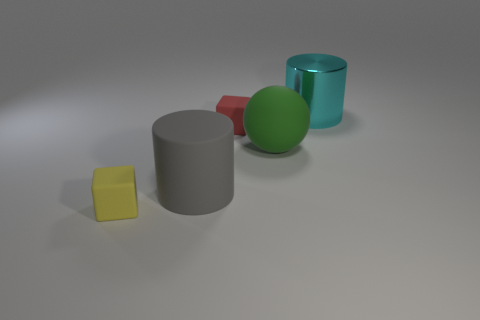Add 2 tiny matte objects. How many objects exist? 7 Subtract all red cubes. How many cubes are left? 1 Subtract all shiny objects. Subtract all tiny brown objects. How many objects are left? 4 Add 4 red things. How many red things are left? 5 Add 2 large rubber cylinders. How many large rubber cylinders exist? 3 Subtract 0 blue blocks. How many objects are left? 5 Subtract all cylinders. How many objects are left? 3 Subtract 2 blocks. How many blocks are left? 0 Subtract all gray cylinders. Subtract all gray blocks. How many cylinders are left? 1 